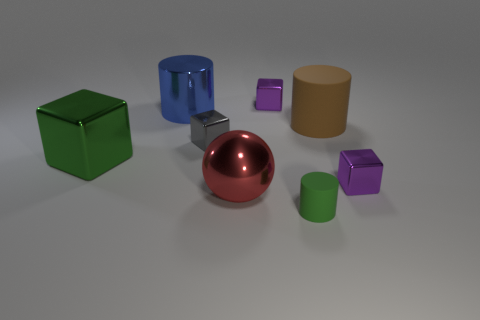Add 1 tiny red metallic things. How many objects exist? 9 Subtract all cylinders. How many objects are left? 5 Add 1 small brown rubber spheres. How many small brown rubber spheres exist? 1 Subtract 0 blue spheres. How many objects are left? 8 Subtract all big brown rubber cylinders. Subtract all tiny yellow rubber things. How many objects are left? 7 Add 2 large blue cylinders. How many large blue cylinders are left? 3 